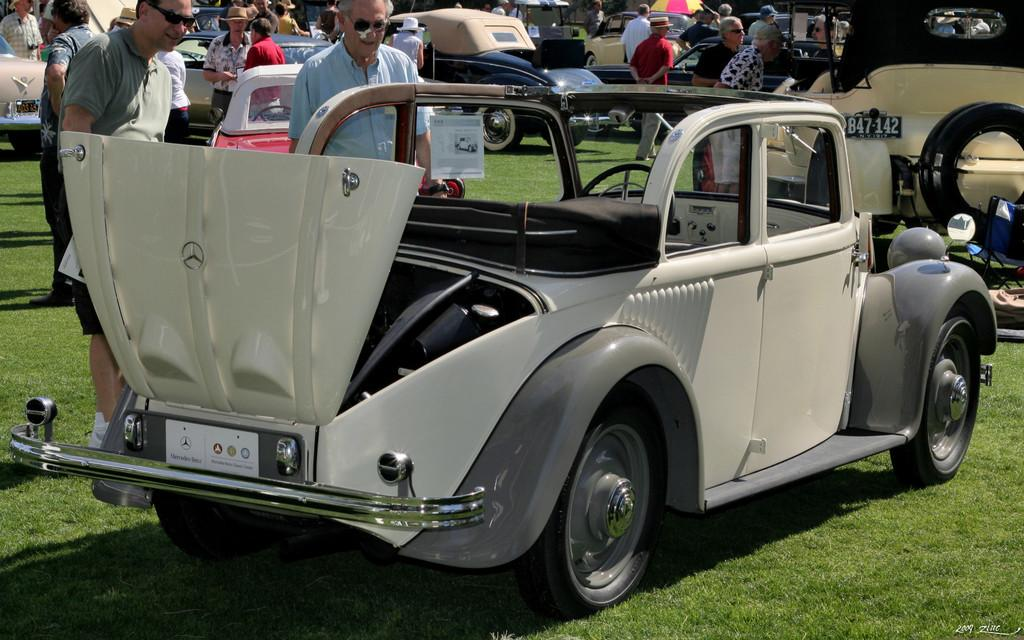Who or what can be seen in the image? There are people and vehicles in the image. What is the surface that the people and vehicles are on? The ground is visible in the image. What object is present to provide shade or protection from the elements? There is an umbrella in the image. What type of vegetation is visible in the image? There is grass visible in the image. How deep is the hole in the image? There is no hole present in the image. Who is the friend of the person standing next to the vehicle? The image does not provide information about friendships or relationships between the people present. 